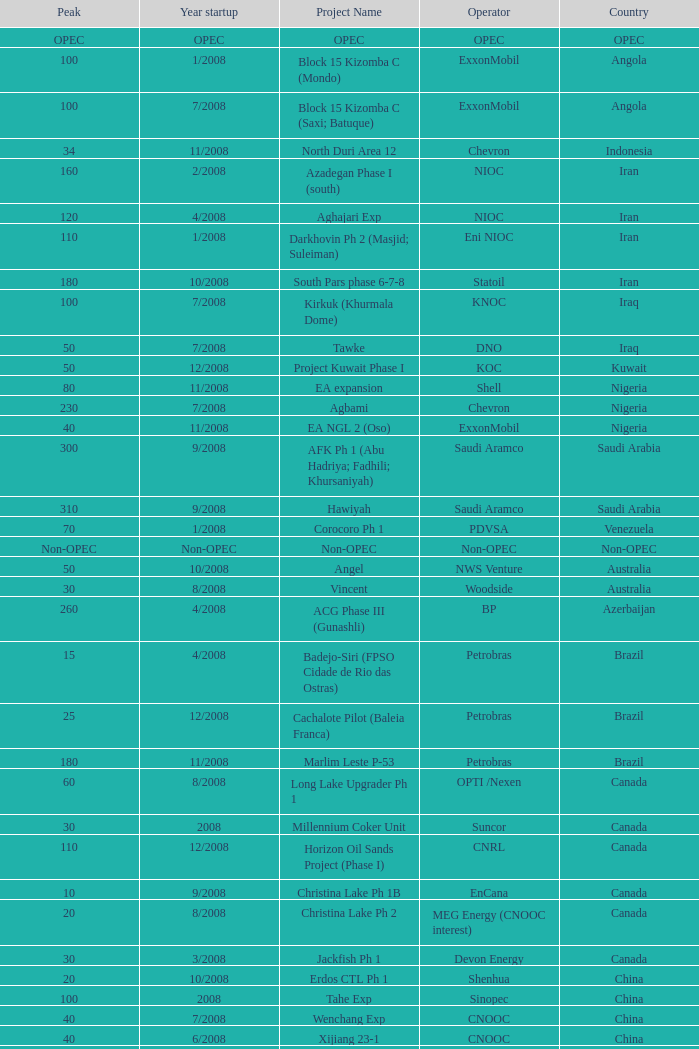Can you parse all the data within this table? {'header': ['Peak', 'Year startup', 'Project Name', 'Operator', 'Country'], 'rows': [['OPEC', 'OPEC', 'OPEC', 'OPEC', 'OPEC'], ['100', '1/2008', 'Block 15 Kizomba C (Mondo)', 'ExxonMobil', 'Angola'], ['100', '7/2008', 'Block 15 Kizomba C (Saxi; Batuque)', 'ExxonMobil', 'Angola'], ['34', '11/2008', 'North Duri Area 12', 'Chevron', 'Indonesia'], ['160', '2/2008', 'Azadegan Phase I (south)', 'NIOC', 'Iran'], ['120', '4/2008', 'Aghajari Exp', 'NIOC', 'Iran'], ['110', '1/2008', 'Darkhovin Ph 2 (Masjid; Suleiman)', 'Eni NIOC', 'Iran'], ['180', '10/2008', 'South Pars phase 6-7-8', 'Statoil', 'Iran'], ['100', '7/2008', 'Kirkuk (Khurmala Dome)', 'KNOC', 'Iraq'], ['50', '7/2008', 'Tawke', 'DNO', 'Iraq'], ['50', '12/2008', 'Project Kuwait Phase I', 'KOC', 'Kuwait'], ['80', '11/2008', 'EA expansion', 'Shell', 'Nigeria'], ['230', '7/2008', 'Agbami', 'Chevron', 'Nigeria'], ['40', '11/2008', 'EA NGL 2 (Oso)', 'ExxonMobil', 'Nigeria'], ['300', '9/2008', 'AFK Ph 1 (Abu Hadriya; Fadhili; Khursaniyah)', 'Saudi Aramco', 'Saudi Arabia'], ['310', '9/2008', 'Hawiyah', 'Saudi Aramco', 'Saudi Arabia'], ['70', '1/2008', 'Corocoro Ph 1', 'PDVSA', 'Venezuela'], ['Non-OPEC', 'Non-OPEC', 'Non-OPEC', 'Non-OPEC', 'Non-OPEC'], ['50', '10/2008', 'Angel', 'NWS Venture', 'Australia'], ['30', '8/2008', 'Vincent', 'Woodside', 'Australia'], ['260', '4/2008', 'ACG Phase III (Gunashli)', 'BP', 'Azerbaijan'], ['15', '4/2008', 'Badejo-Siri (FPSO Cidade de Rio das Ostras)', 'Petrobras', 'Brazil'], ['25', '12/2008', 'Cachalote Pilot (Baleia Franca)', 'Petrobras', 'Brazil'], ['180', '11/2008', 'Marlim Leste P-53', 'Petrobras', 'Brazil'], ['60', '8/2008', 'Long Lake Upgrader Ph 1', 'OPTI /Nexen', 'Canada'], ['30', '2008', 'Millennium Coker Unit', 'Suncor', 'Canada'], ['110', '12/2008', 'Horizon Oil Sands Project (Phase I)', 'CNRL', 'Canada'], ['10', '9/2008', 'Christina Lake Ph 1B', 'EnCana', 'Canada'], ['20', '8/2008', 'Christina Lake Ph 2', 'MEG Energy (CNOOC interest)', 'Canada'], ['30', '3/2008', 'Jackfish Ph 1', 'Devon Energy', 'Canada'], ['20', '10/2008', 'Erdos CTL Ph 1', 'Shenhua', 'China'], ['100', '2008', 'Tahe Exp', 'Sinopec', 'China'], ['40', '7/2008', 'Wenchang Exp', 'CNOOC', 'China'], ['40', '6/2008', 'Xijiang 23-1', 'CNOOC', 'China'], ['90', '4/2008', 'Moho Bilondo', 'Total', 'Congo'], ['40', '3/2008', 'Saqqara', 'BP', 'Egypt'], ['40', '9/2008', 'MA field (KG-D6)', 'Reliance', 'India'], ['150', '3/2008', 'Dunga', 'Maersk', 'Kazakhstan'], ['10', '5/2008', 'Komsomolskoe', 'Petrom', 'Kazakhstan'], ['200', '2008', '( Chicontepec ) Exp 1', 'PEMEX', 'Mexico'], ['20', '5/2008', 'Antonio J Bermudez Exp', 'PEMEX', 'Mexico'], ['20', '5/2008', 'Bellota Chinchorro Exp', 'PEMEX', 'Mexico'], ['55', '2008', 'Ixtal Manik', 'PEMEX', 'Mexico'], ['15', '2008', 'Jujo Tecominoacan Exp', 'PEMEX', 'Mexico'], ['100', '6/2008', 'Alvheim; Volund; Vilje', 'Marathon', 'Norway'], ['35', '2/2008', 'Volve', 'StatoilHydro', 'Norway'], ['40', '2008', 'Mukhaizna EOR Ph 1', 'Occidental', 'Oman'], ['15', '10/2008', 'Galoc', 'GPC', 'Philippines'], ['60', '10/2008', 'Talakan Ph 1', 'Surgutneftegaz', 'Russia'], ['20', '10/2008', 'Verkhnechonsk Ph 1 (early oil)', 'TNK-BP Rosneft', 'Russia'], ['75', '8/2008', 'Yuzhno-Khylchuyuskoye "YK" Ph 1', 'Lukoil ConocoPhillips', 'Russia'], ['10', '8/2008', 'Bualuang', 'Salamander', 'Thailand'], ['25', '7/2008', 'Britannia Satellites (Callanish; Brodgar)', 'Conoco Phillips', 'UK'], ['45', '11/2008', 'Blind Faith', 'Chevron', 'USA'], ['25', '7/2008', 'Neptune', 'BHP Billiton', 'USA'], ['15', '6/2008', 'Oooguruk', 'Pioneer', 'USA'], ['4', '7/2008', 'Qannik', 'ConocoPhillips', 'USA'], ['210', '6/2008', 'Thunder Horse', 'BP', 'USA'], ['30', '1/2008', 'Ursa Princess Exp', 'Shell', 'USA'], ['15', '7/2008', 'Ca Ngu Vang (Golden Tuna)', 'HVJOC', 'Vietnam'], ['40', '10/2008', 'Su Tu Vang', 'Cuu Long Joint', 'Vietnam'], ['10', '12/2008', 'Song Doc', 'Talisman', 'Vietnam']]} What is the Peak with a Project Name that is talakan ph 1? 60.0. 